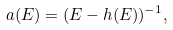Convert formula to latex. <formula><loc_0><loc_0><loc_500><loc_500>a ( E ) = ( E - h ( E ) ) ^ { - 1 } ,</formula> 